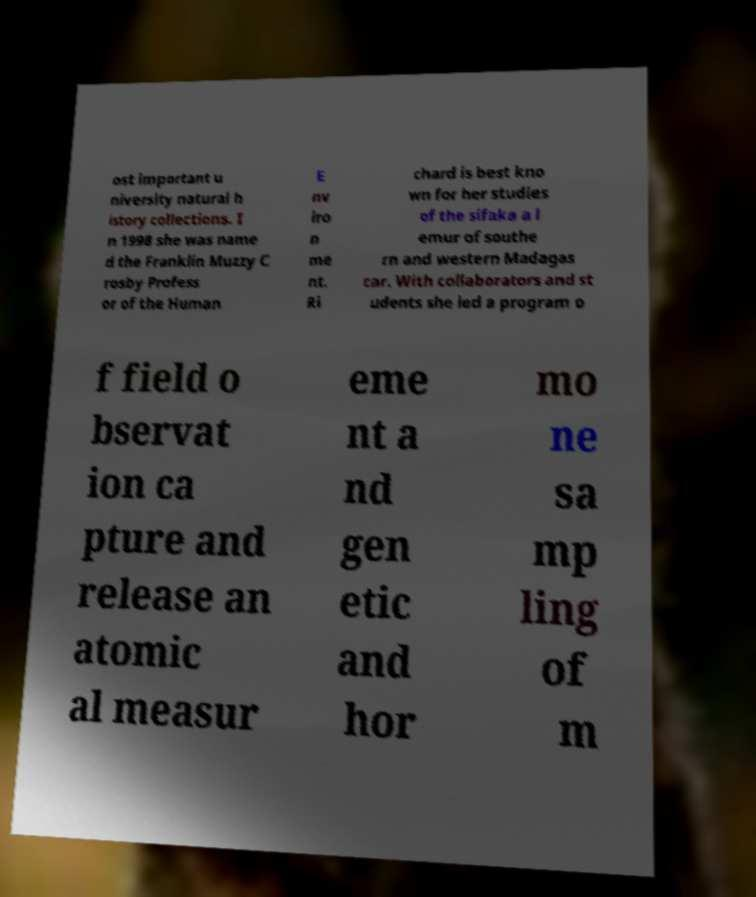I need the written content from this picture converted into text. Can you do that? ost important u niversity natural h istory collections. I n 1998 she was name d the Franklin Muzzy C rosby Profess or of the Human E nv iro n me nt. Ri chard is best kno wn for her studies of the sifaka a l emur of southe rn and western Madagas car. With collaborators and st udents she led a program o f field o bservat ion ca pture and release an atomic al measur eme nt a nd gen etic and hor mo ne sa mp ling of m 